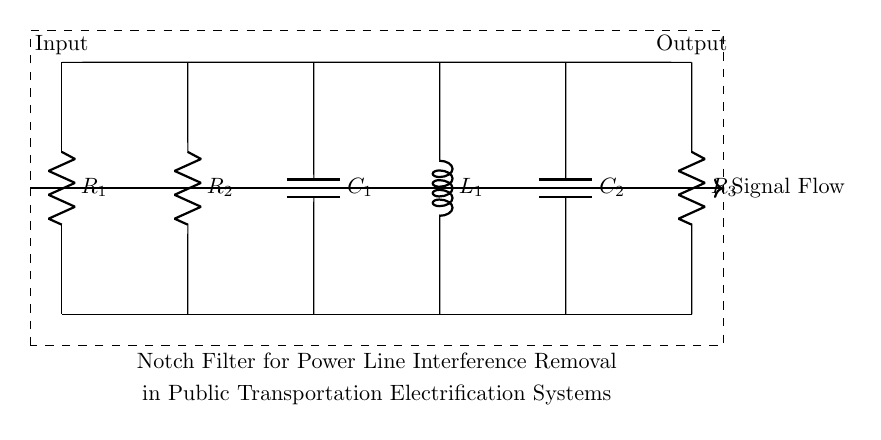What is the type of this filter? This circuit implements a notch filter, which is specifically designed to eliminate narrow bands of frequency interference, such as power line interference. This is indicated by the arrangement of capacitors and inductors in the circuit.
Answer: Notch filter What are the components used in this circuit? The circuit consists of resistors, capacitors, and an inductor, which are essential elements for implementing filtering action. Specifically, there are three resistors, two capacitors, and one inductor visible in the diagram.
Answer: Three resistors, two capacitors, one inductor What is the input of the circuit? The circuit's input is identified as the leftmost point labeled "Input," where the signal enters the system for filtering. It's crucial as this is where the interference is first encountered.
Answer: Input How many resistors are present in this circuit? The circuit contains three resistors, clearly labeled R1, R2, and R3, which are used to control the current flow and shape the frequency response of the notch filter.
Answer: Three Which components are connected in parallel? The capacitors C1 and C2 are in parallel, and this configuration helps to create a frequency response that selectively filters out the targeted interference frequency. Both capacitors connect to the ground and influence the filter characteristics together.
Answer: C1 and C2 What type of filtering action does this circuit primarily provide? This circuit primarily provides attenuation of specific frequency interference, specifically power line noise, through the notch filter design that selectively removes those frequencies while allowing others to pass.
Answer: Attenuation What is the purpose of the inductor in this notch filter? The inductor, labeled L1 in the circuit, works in conjunction with the capacitors to create the notch effect, helping to define the specific frequency range that will be attenuated, thus improving the overall signal quality by removing unwanted noise.
Answer: Create notch effect 